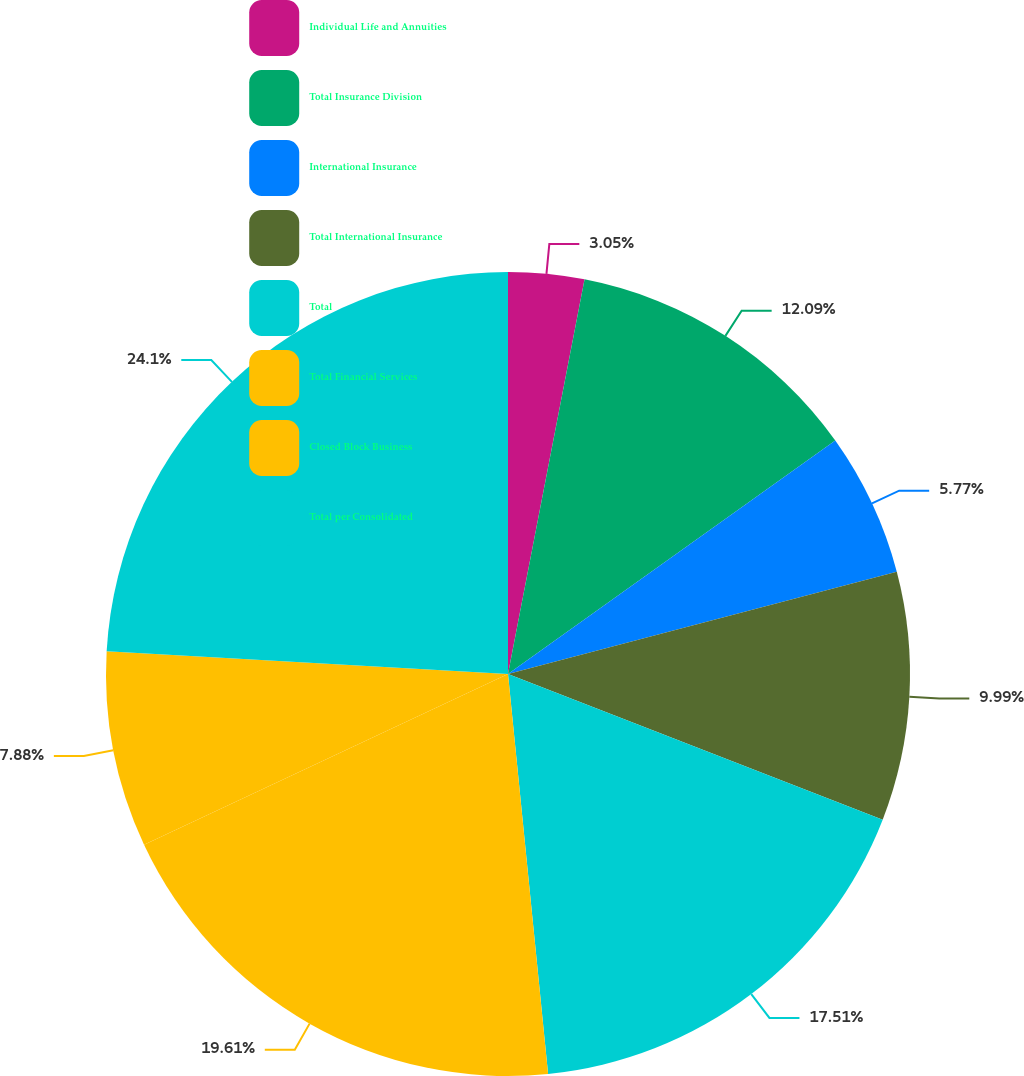Convert chart. <chart><loc_0><loc_0><loc_500><loc_500><pie_chart><fcel>Individual Life and Annuities<fcel>Total Insurance Division<fcel>International Insurance<fcel>Total International Insurance<fcel>Total<fcel>Total Financial Services<fcel>Closed Block Business<fcel>Total per Consolidated<nl><fcel>3.05%<fcel>12.09%<fcel>5.77%<fcel>9.99%<fcel>17.51%<fcel>19.61%<fcel>7.88%<fcel>24.1%<nl></chart> 